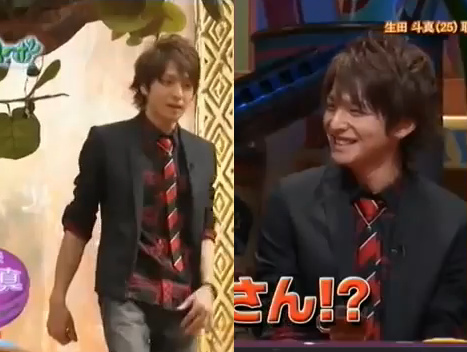Is the sitting man that is to the right of the other man old and happy? No, the man sitting to the right is not old and happy. 